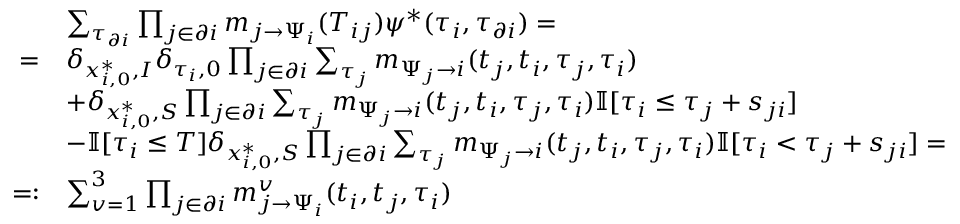<formula> <loc_0><loc_0><loc_500><loc_500>\begin{array} { r l } & { \sum _ { \tau _ { \partial i } } \prod _ { j \in \partial i } m _ { j \to \Psi _ { i } } ( T _ { i j } ) \psi ^ { * } ( \tau _ { i } , \tau _ { \partial i } ) = } \\ { = } & { \delta _ { x _ { i , 0 } ^ { * } , I } \delta _ { \tau _ { i } , 0 } \prod _ { j \in \partial i } \sum _ { \tau _ { j } } m _ { \Psi _ { j } \to i } ( t _ { j } , t _ { i } , \tau _ { j } , \tau _ { i } ) } \\ & { + \delta _ { x _ { i , 0 } ^ { * } , S } \prod _ { j \in \partial i } \sum _ { \tau _ { j } } m _ { \Psi _ { j } \to i } ( t _ { j } , t _ { i } , \tau _ { j } , \tau _ { i } ) \mathbb { I } [ \tau _ { i } \leq \tau _ { j } + s _ { j i } ] } \\ & { - \mathbb { I } [ \tau _ { i } \leq T ] \delta _ { x _ { i , 0 } ^ { * } , S } \prod _ { j \in \partial i } \sum _ { \tau _ { j } } m _ { \Psi _ { j } \to i } ( t _ { j } , t _ { i } , \tau _ { j } , \tau _ { i } ) \mathbb { I } [ \tau _ { i } < \tau _ { j } + s _ { j i } ] = } \\ { = \colon } & { \sum _ { v = 1 } ^ { 3 } \prod _ { j \in \partial i } m _ { j \to \Psi _ { i } } ^ { v } ( t _ { i } , t _ { j } , \tau _ { i } ) } \end{array}</formula> 